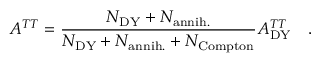Convert formula to latex. <formula><loc_0><loc_0><loc_500><loc_500>A ^ { T T } = \frac { N _ { D Y } + N _ { a n n i h . } } { N _ { D Y } + N _ { a n n i h . } + N _ { C o m p t o n } } A _ { D Y } ^ { T T } \quad .</formula> 